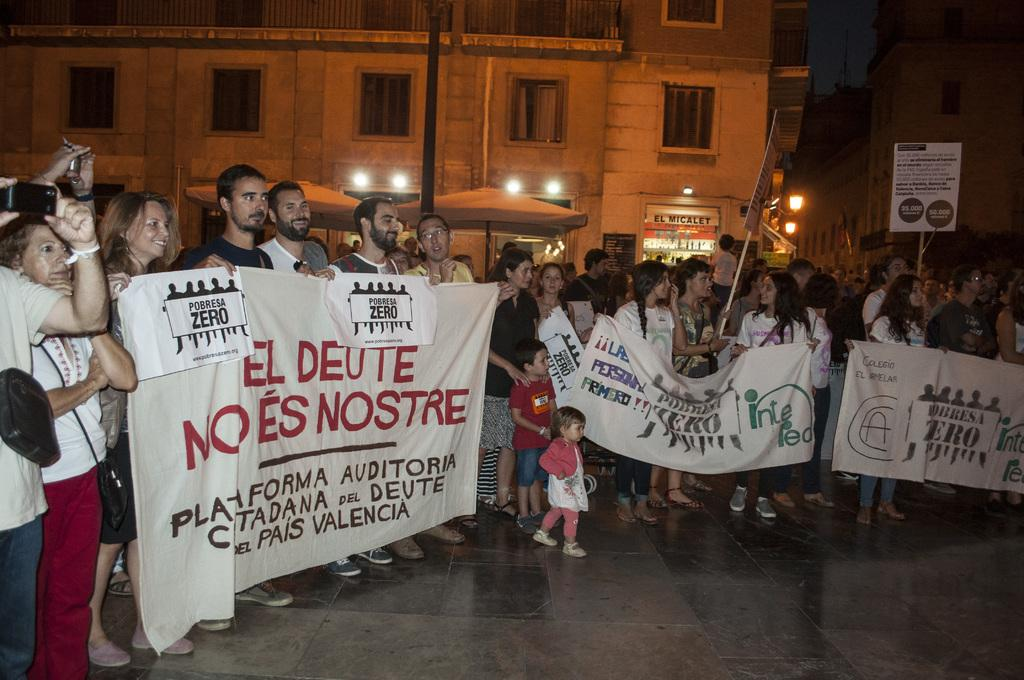What are the people in the image doing? The people in the image are standing and holding banners with text. What can be seen on the banners? The banners have text on them. What is visible at the bottom of the image? There is a floor visible at the bottom of the image. What can be seen in the distance in the image? There are buildings and lights in the background of the image. What type of fuel is being used by the daughter in the image? There is no daughter or fuel present in the image. What kind of bait is being used by the people holding banners in the image? There is no bait present in the image; the people are holding banners with text. 